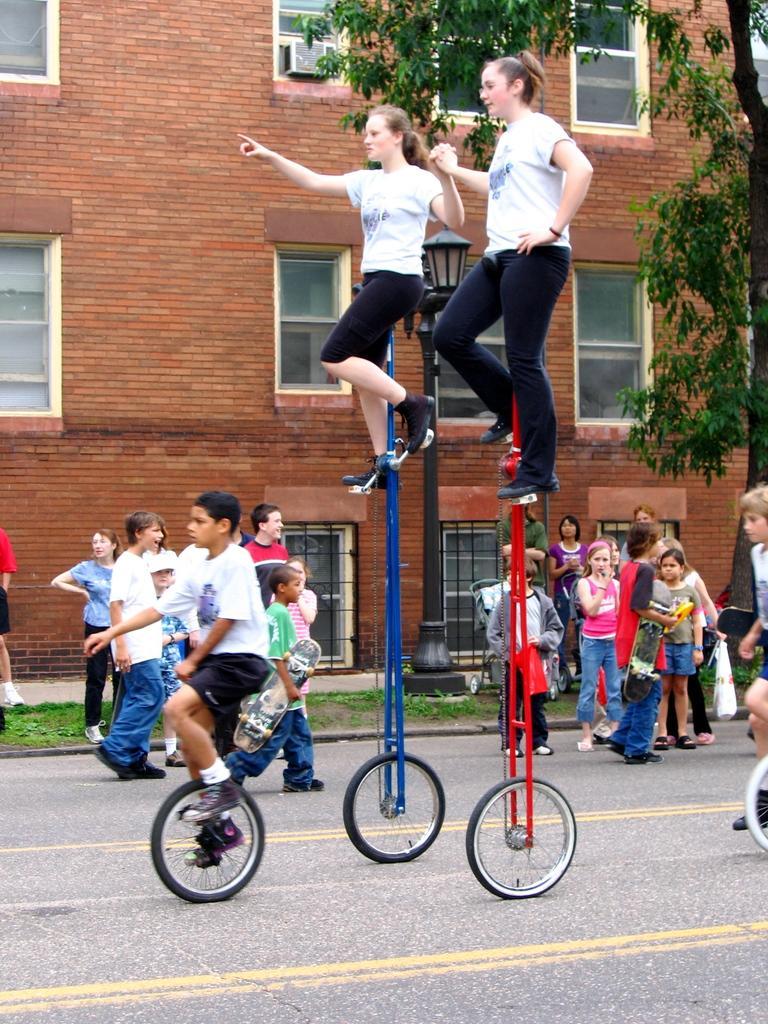How would you summarize this image in a sentence or two? In this picture we can see four persons riding bicycles, in the background there are some people standing, we can see a building here, on the right side there is a tree, we can see windows of the building here. 